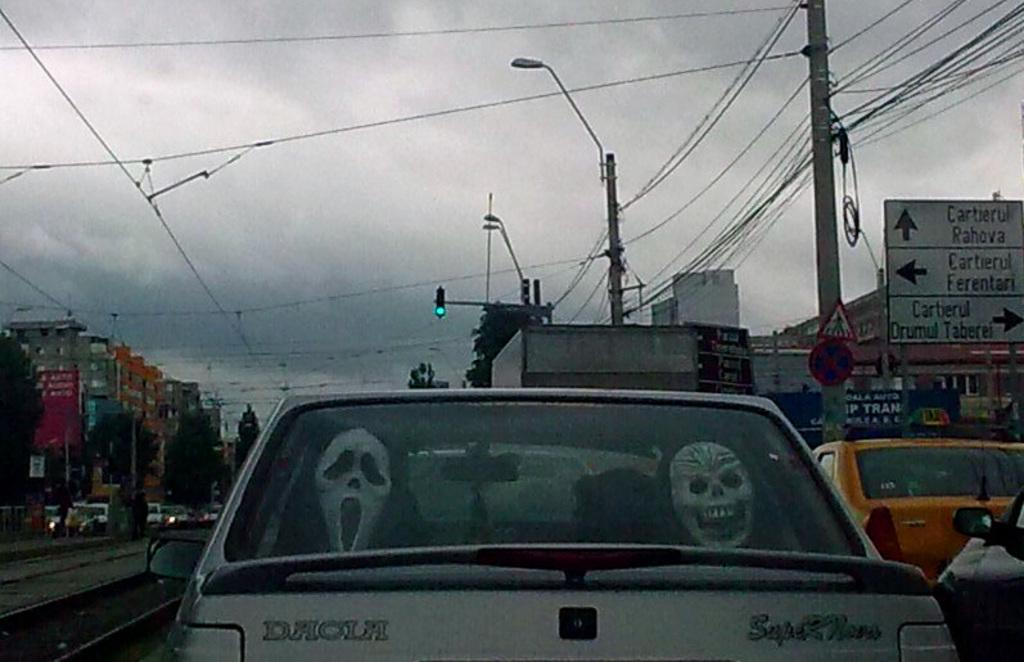<image>
Present a compact description of the photo's key features. A grey car has two Halloween masks in the back window and is driving past a sign that says Cartierul Rahova. 